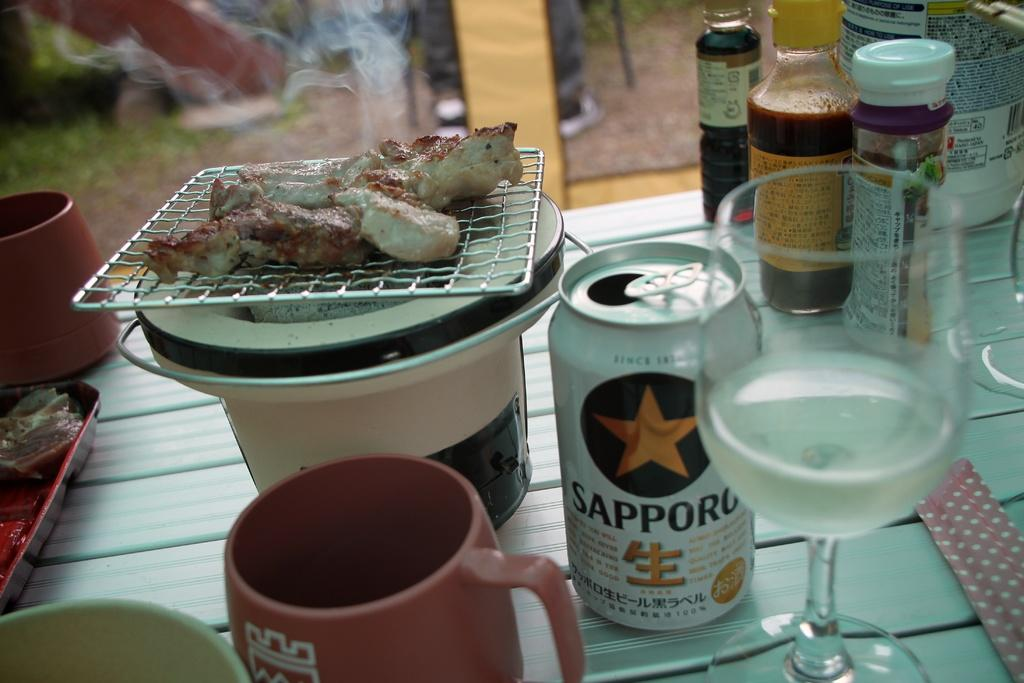What type of containers are present in the image? There are mugs and bottles in the image. What else can be seen in the image besides containers? There are food items and a glass in the image. How many seats are visible in the image? There are no seats present in the image. Is there a camp set up in the image? There is no camp present in the image. 